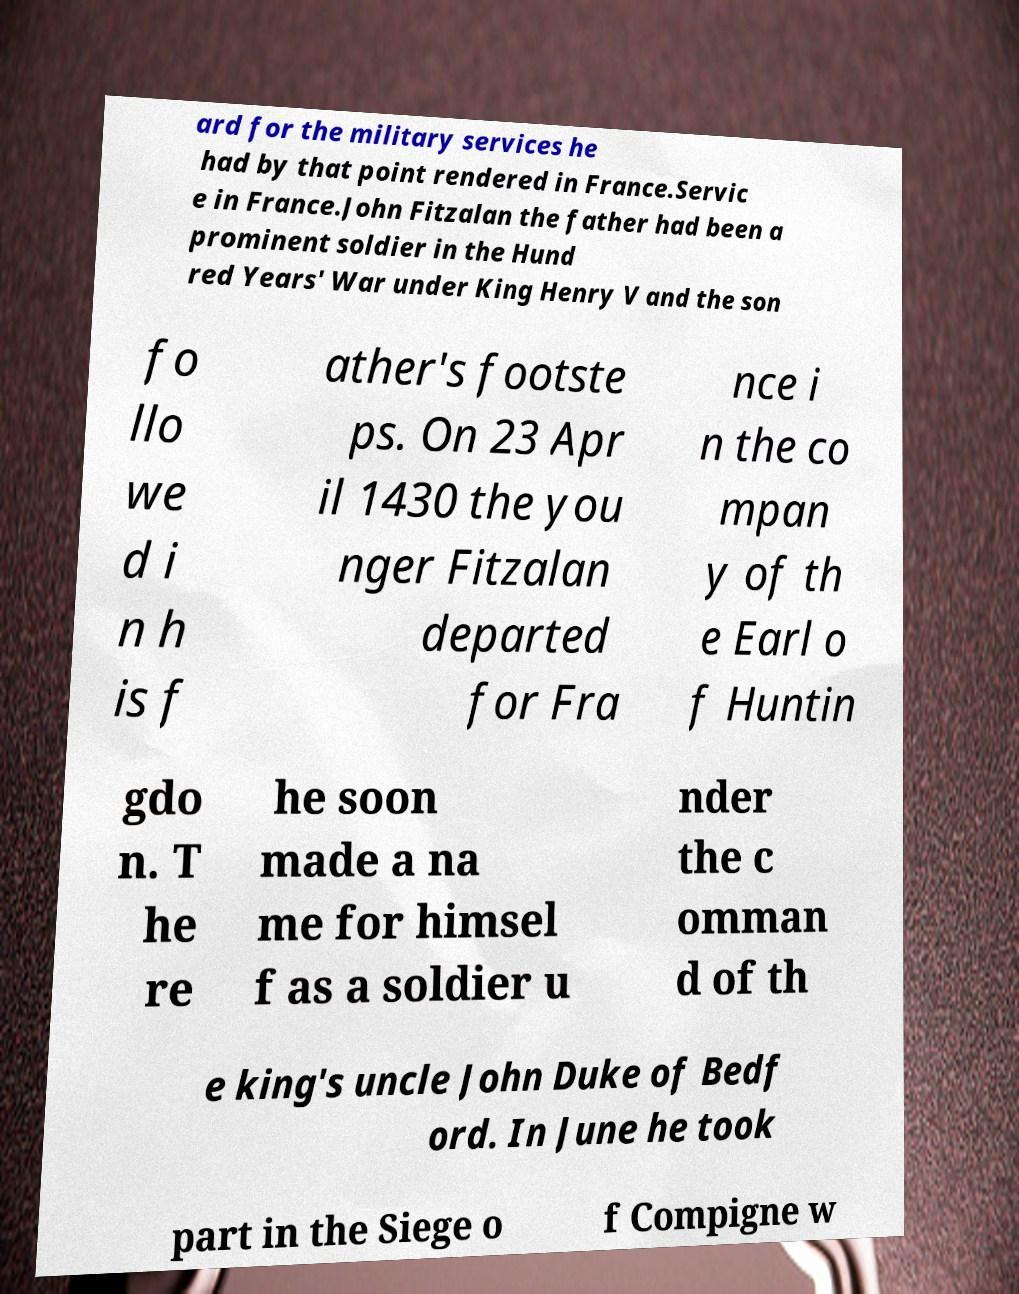Could you assist in decoding the text presented in this image and type it out clearly? ard for the military services he had by that point rendered in France.Servic e in France.John Fitzalan the father had been a prominent soldier in the Hund red Years' War under King Henry V and the son fo llo we d i n h is f ather's footste ps. On 23 Apr il 1430 the you nger Fitzalan departed for Fra nce i n the co mpan y of th e Earl o f Huntin gdo n. T he re he soon made a na me for himsel f as a soldier u nder the c omman d of th e king's uncle John Duke of Bedf ord. In June he took part in the Siege o f Compigne w 